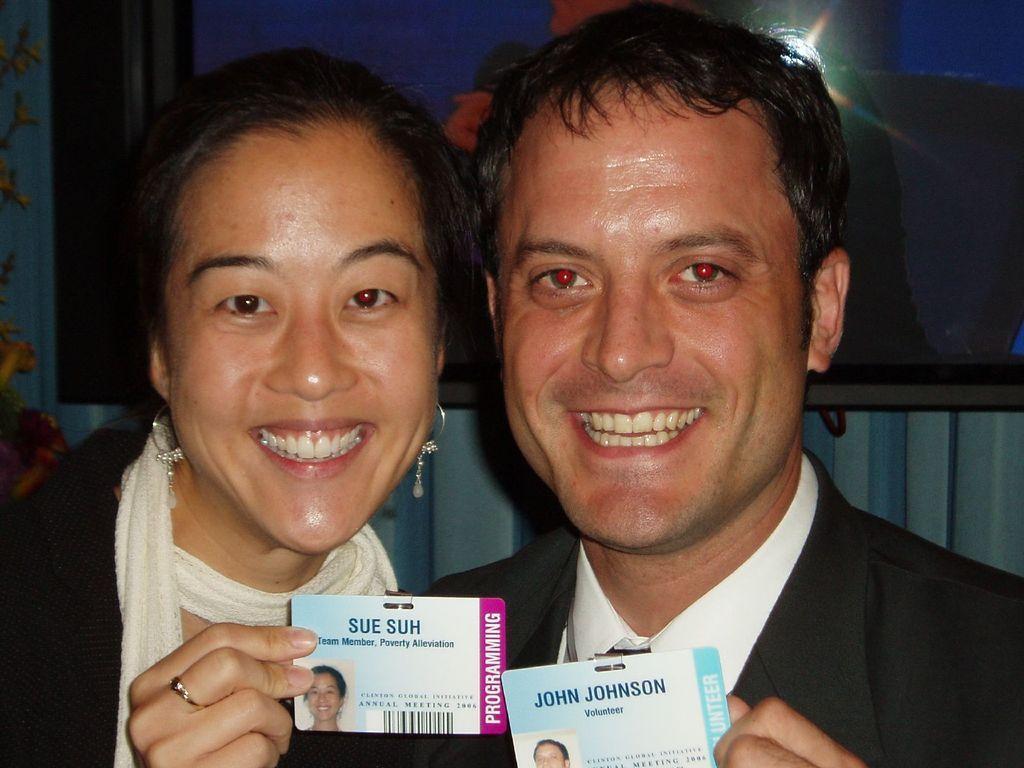In one or two sentences, can you explain what this image depicts? In the picture there is a man and a woman laughing, they are catching identity cards with the hands, behind them there is a wall, on the wall there may be a frame. 